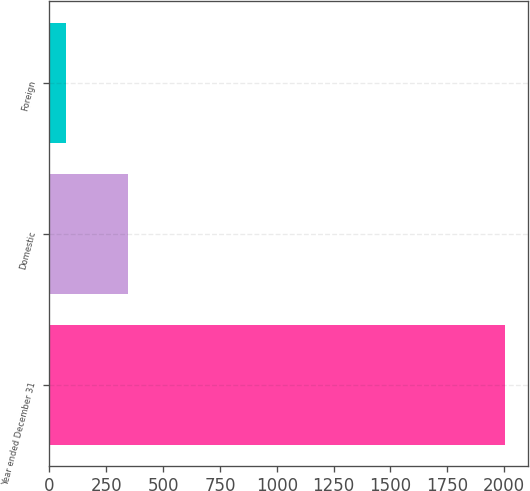Convert chart to OTSL. <chart><loc_0><loc_0><loc_500><loc_500><bar_chart><fcel>Year ended December 31<fcel>Domestic<fcel>Foreign<nl><fcel>2004<fcel>347.7<fcel>74.9<nl></chart> 